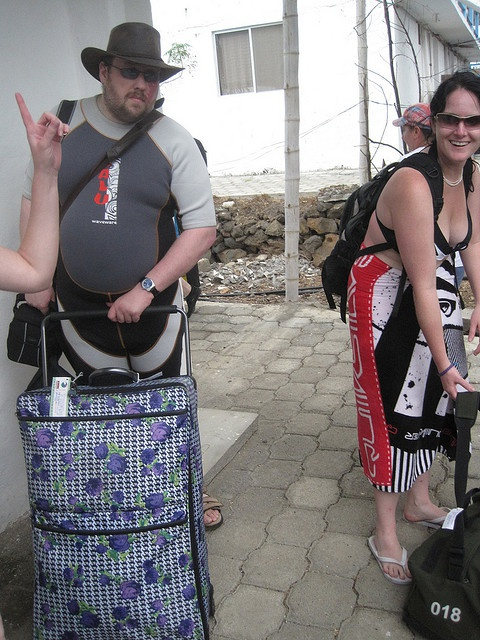Describe the objects in this image and their specific colors. I can see suitcase in gray, black, and navy tones, people in gray, black, darkgray, and lightgray tones, people in gray, black, and darkgray tones, people in gray, darkgray, and pink tones, and backpack in gray, black, darkgray, and maroon tones in this image. 